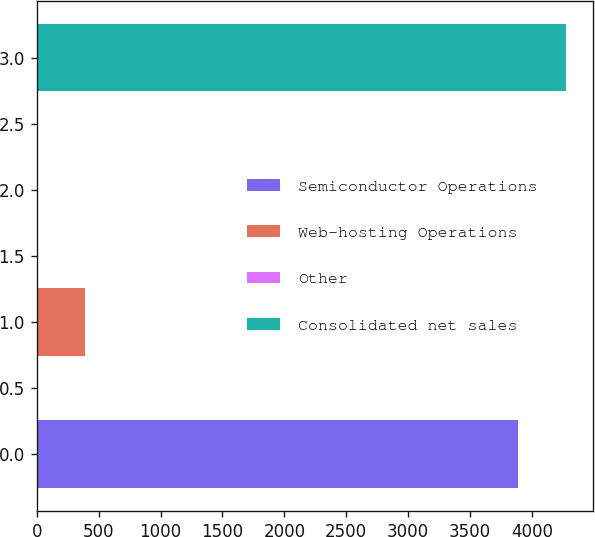Convert chart to OTSL. <chart><loc_0><loc_0><loc_500><loc_500><bar_chart><fcel>Semiconductor Operations<fcel>Web-hosting Operations<fcel>Other<fcel>Consolidated net sales<nl><fcel>3882.6<fcel>393.86<fcel>0.3<fcel>4276.16<nl></chart> 